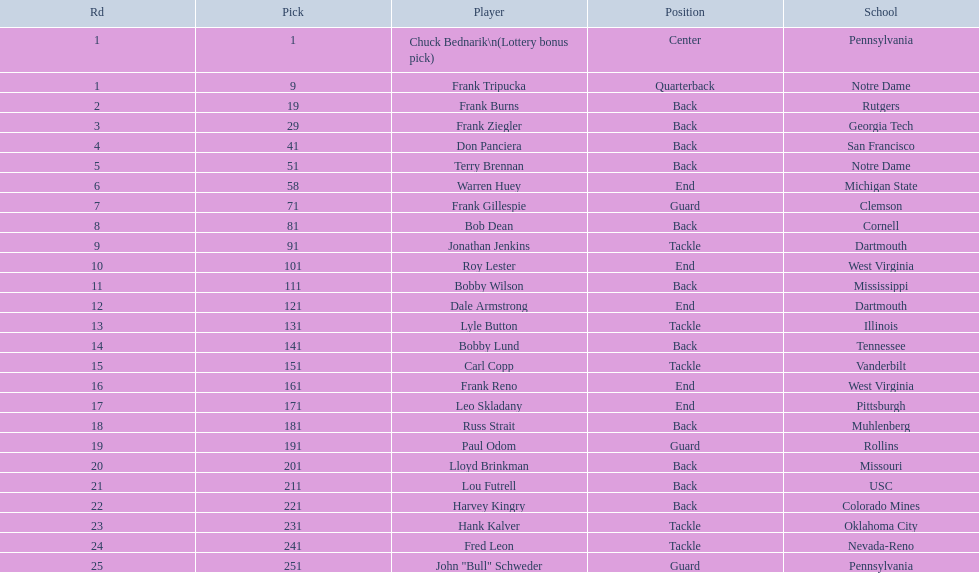Who was selected following roy lester? Bobby Wilson. 